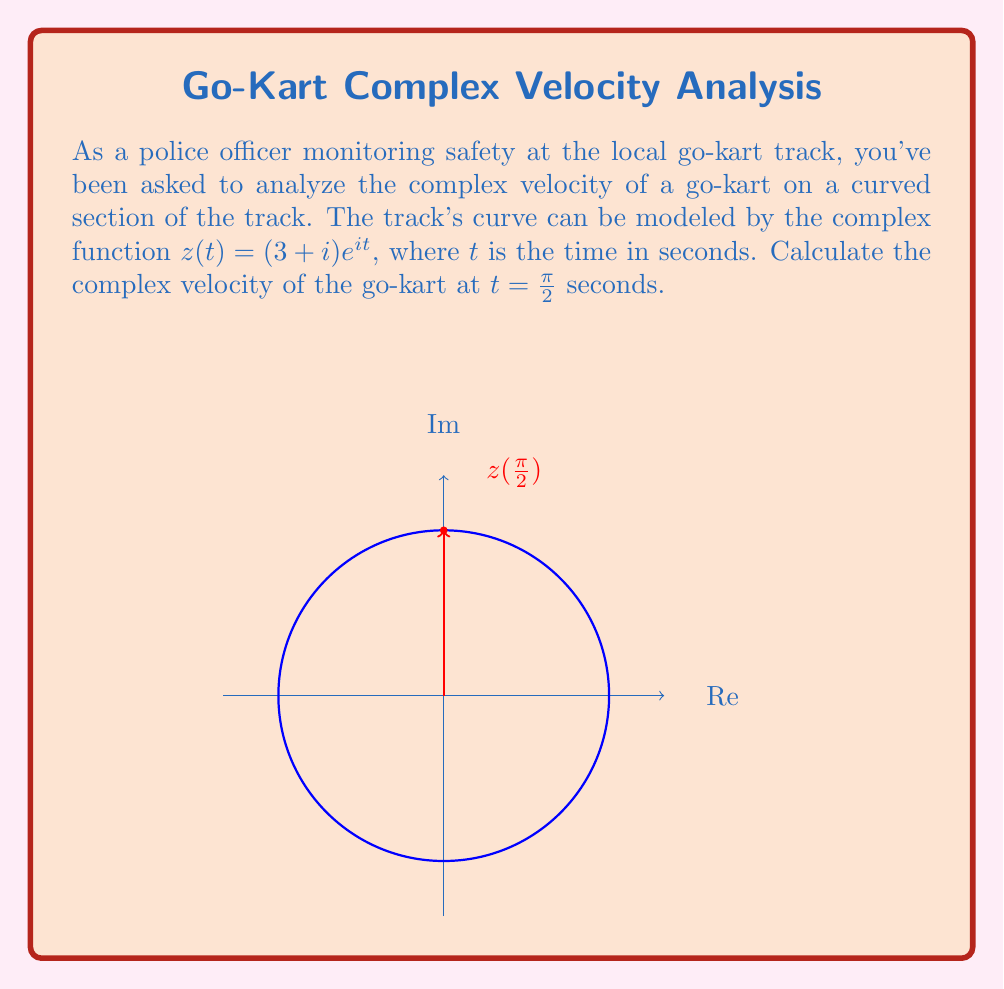Show me your answer to this math problem. To find the complex velocity, we need to differentiate the position function $z(t)$ with respect to time:

1) The position function is given as:
   $$z(t) = (3+i)e^{it}$$

2) To find velocity, we differentiate $z(t)$ with respect to $t$:
   $$\frac{dz}{dt} = (3+i) \cdot i \cdot e^{it}$$
   $$v(t) = i(3+i)e^{it}$$

3) This gives us the general complex velocity function. To find the velocity at $t = \frac{\pi}{2}$, we substitute this value:
   $$v(\frac{\pi}{2}) = i(3+i)e^{i\frac{\pi}{2}}$$

4) Recall that $e^{i\frac{\pi}{2}} = i$:
   $$v(\frac{\pi}{2}) = i(3+i)i$$

5) Simplify:
   $$v(\frac{\pi}{2}) = i(3i-1)$$
   $$v(\frac{\pi}{2}) = -3 - i$$

Therefore, the complex velocity at $t = \frac{\pi}{2}$ seconds is $-3 - i$.
Answer: $-3 - i$ 